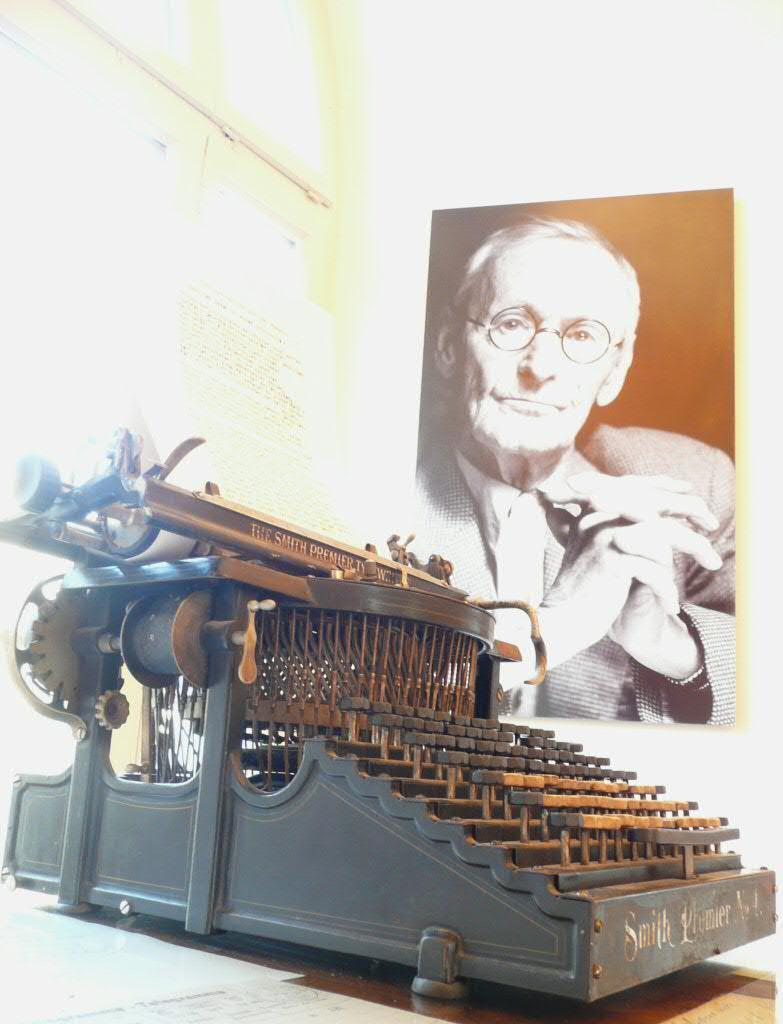What object is on the table in the image? There is a typewriter on the table in the image. What is the typewriter being used for? The typewriter has text on it, indicating that it is being used for typing. What can be seen in the photo frame in the image? There is a photo frame of a person in the image. Where is the photo frame located? The photo frame is attached to the wall. What type of shoe is visible in the image? There is no shoe present in the image. Is there a baseball game happening in the image? There is no baseball game or any reference to baseball in the image. 